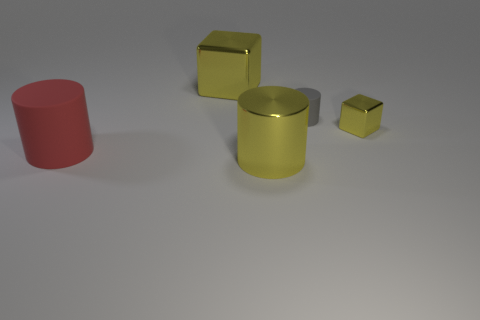Subtract all yellow shiny cylinders. How many cylinders are left? 2 Add 2 small cylinders. How many objects exist? 7 Subtract all yellow cylinders. How many cylinders are left? 2 Subtract 1 blocks. How many blocks are left? 1 Add 5 yellow things. How many yellow things are left? 8 Add 5 large red things. How many large red things exist? 6 Subtract 0 cyan balls. How many objects are left? 5 Subtract all cubes. How many objects are left? 3 Subtract all blue cylinders. Subtract all yellow spheres. How many cylinders are left? 3 Subtract all tiny blue cubes. Subtract all small yellow objects. How many objects are left? 4 